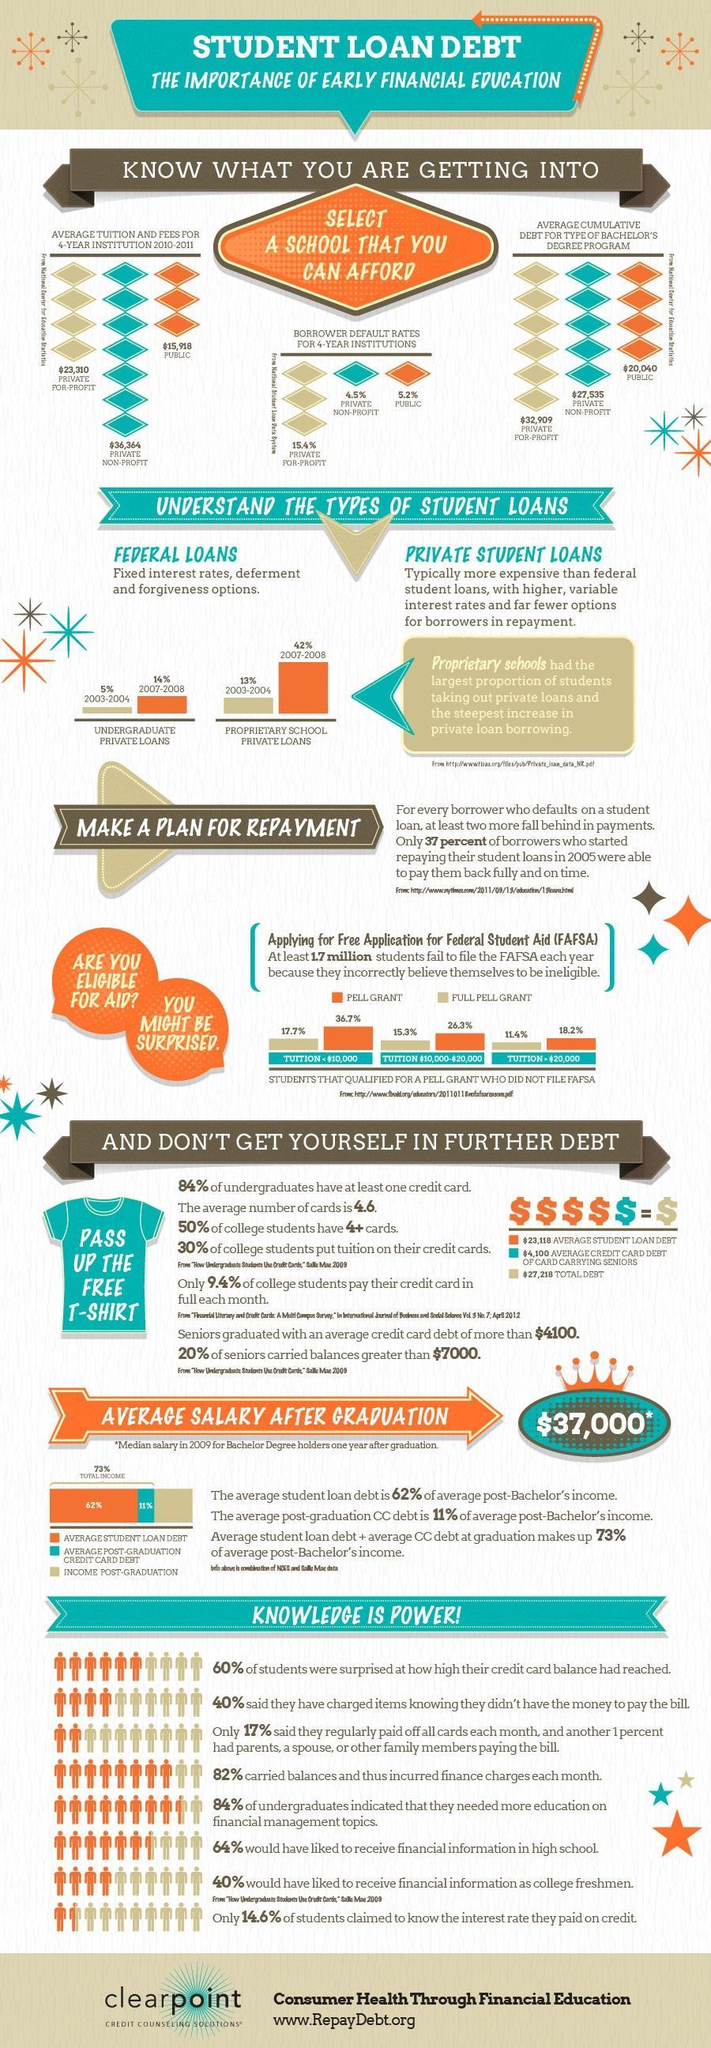How many types of student loans mentioned in this infographic?
Answer the question with a short phrase. 2 